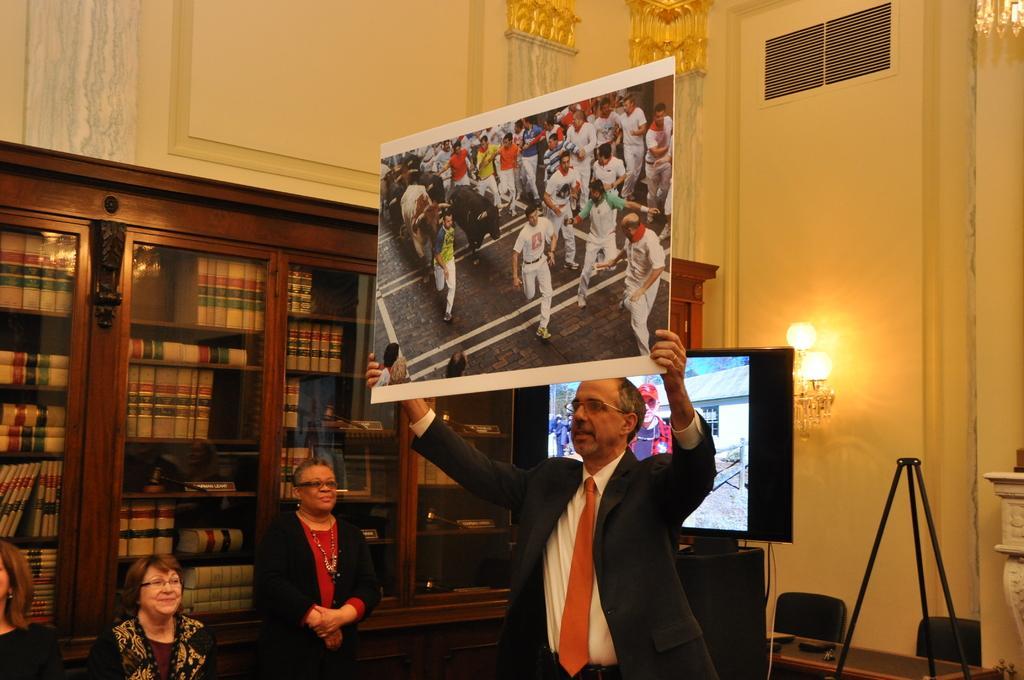Could you give a brief overview of what you see in this image? In this image I can see a man is holding a board which has a picture on it. In this picture I can see people on the road. In the background I can see women, TV screen, wooden book glass shelves which has books, lights attached to the wall and other objects on the floor. 